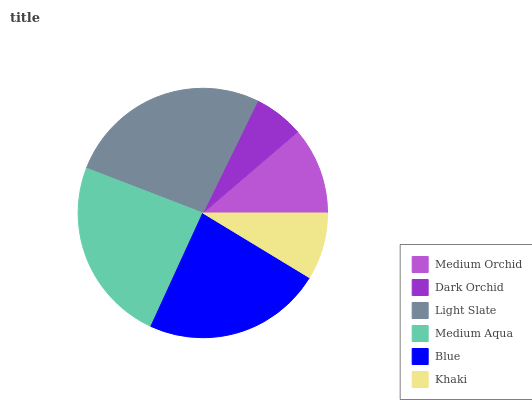Is Dark Orchid the minimum?
Answer yes or no. Yes. Is Light Slate the maximum?
Answer yes or no. Yes. Is Light Slate the minimum?
Answer yes or no. No. Is Dark Orchid the maximum?
Answer yes or no. No. Is Light Slate greater than Dark Orchid?
Answer yes or no. Yes. Is Dark Orchid less than Light Slate?
Answer yes or no. Yes. Is Dark Orchid greater than Light Slate?
Answer yes or no. No. Is Light Slate less than Dark Orchid?
Answer yes or no. No. Is Blue the high median?
Answer yes or no. Yes. Is Medium Orchid the low median?
Answer yes or no. Yes. Is Dark Orchid the high median?
Answer yes or no. No. Is Dark Orchid the low median?
Answer yes or no. No. 